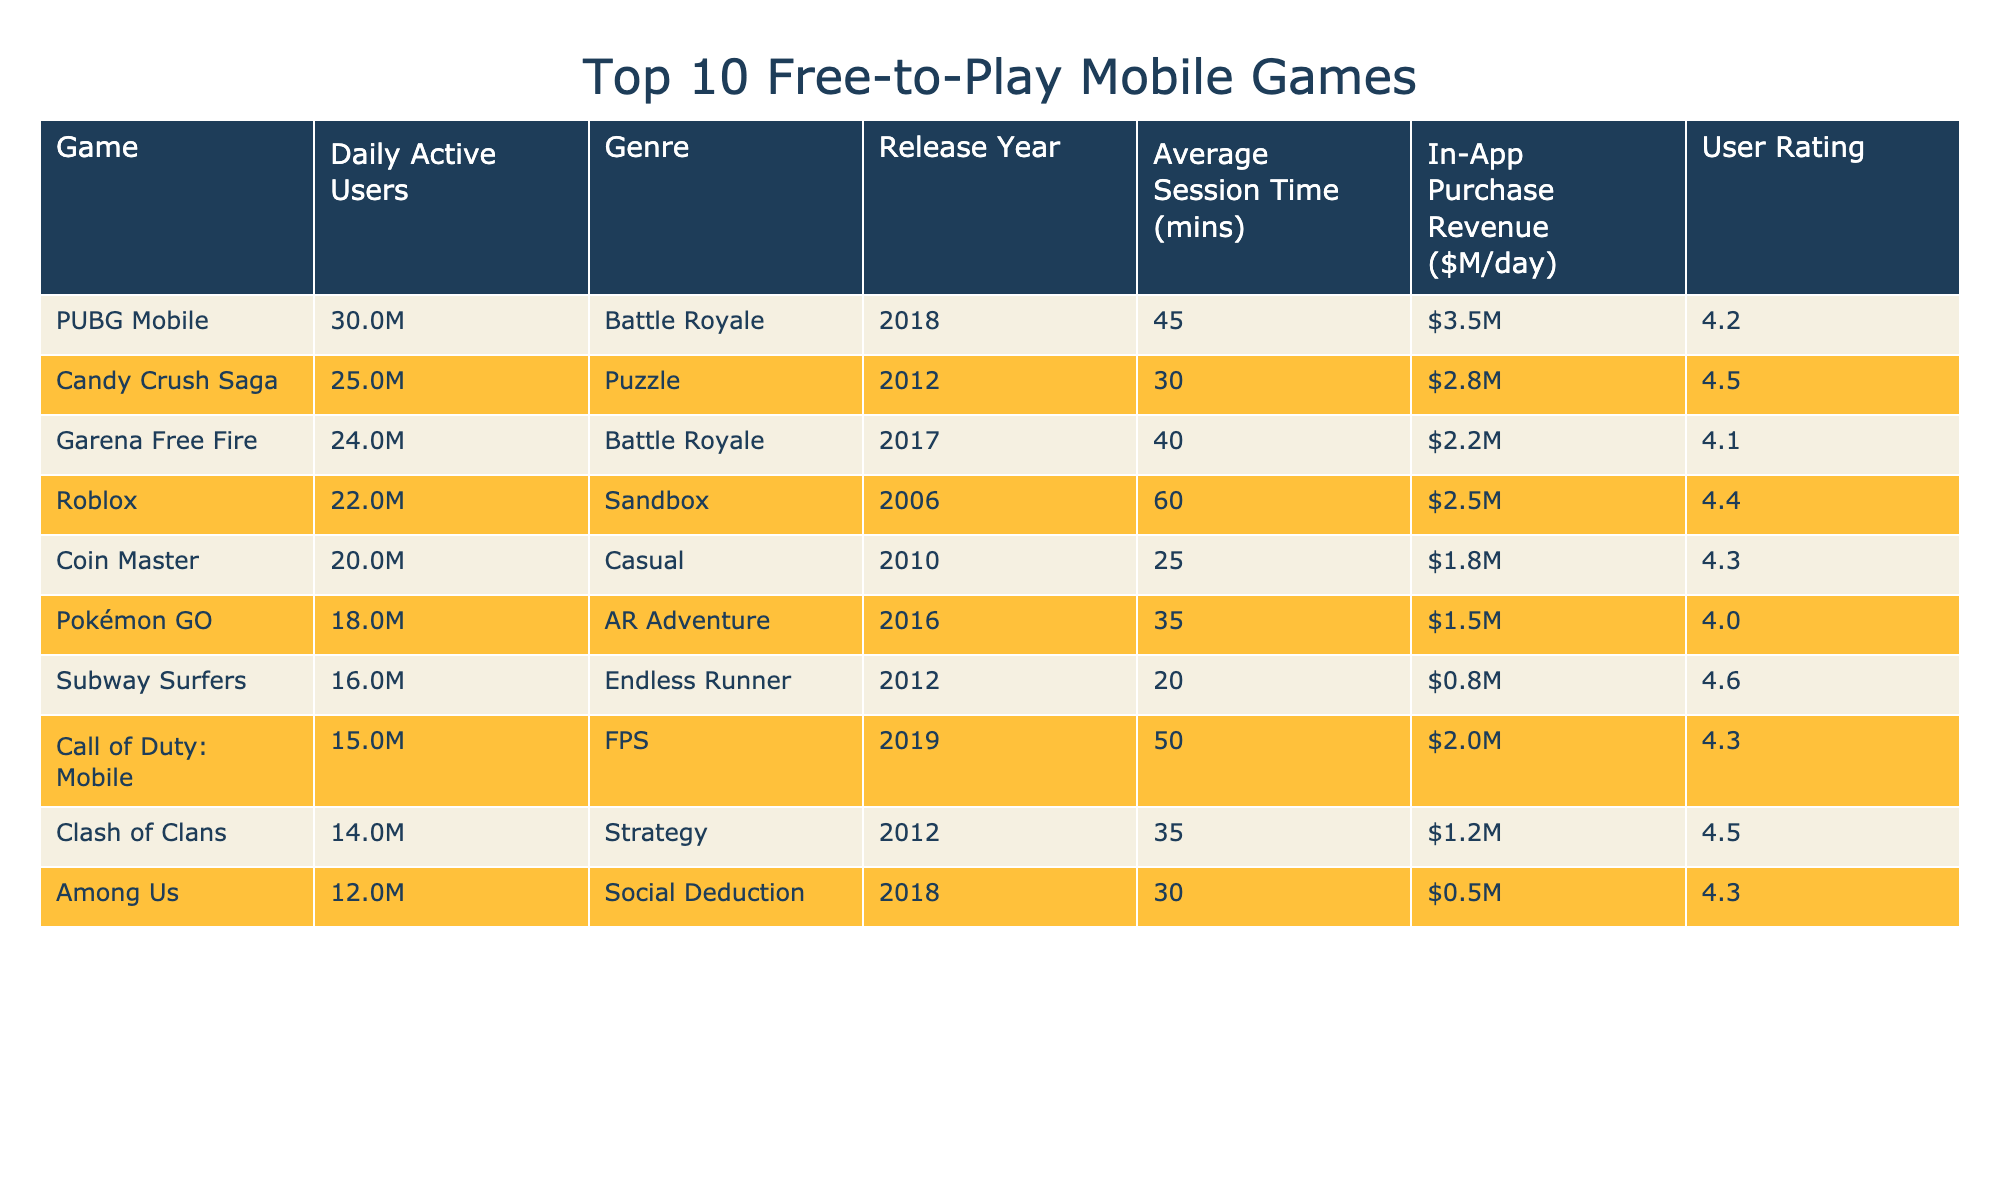What's the game with the highest daily active users? Referring to the table, the game with the highest daily active users is PUBG Mobile, which has 30,000,000 users.
Answer: PUBG Mobile Which game was released most recently? Looking at the release year column, Call of Duty: Mobile was released in 2019, making it the most recent game on the list.
Answer: Call of Duty: Mobile What is the average user rating of the top 10 games? To find the average user rating, we add all the ratings: (4.2 + 4.5 + 4.1 + 4.4 + 4.3 + 4.0 + 4.6 + 4.3 + 4.5 + 4.3) = 43.3, divide by 10 gives us an average of 4.33.
Answer: 4.3 Is there a significant difference between the daily active users of Candy Crush Saga and Call of Duty: Mobile? Candy Crush Saga has 25,000,000 daily active users while Call of Duty: Mobile has 15,000,000. The difference is 10,000,000, which is significant.
Answer: Yes Which genre has the highest average session time? The session times are: Battle Royale (45, 40), Puzzle (30), Sandbox (60), Casual (25), AR Adventure (35), Endless Runner (20), FPS (50), Strategy (35), Social Deduction (30). The highest average session time comes from Roblox at 60 minutes.
Answer: Sandbox How many games have more than 20 million daily active users? From the table, the games with more than 20 million users are PUBG Mobile, Candy Crush Saga, Garena Free Fire, Roblox, and Coin Master, totaling five games.
Answer: 5 What is the in-app purchase revenue of Subway Surfers? The revenue column shows that Subway Surfers has an in-app purchase revenue of $0.8 million per day.
Answer: $0.8M Is the user rating of Pokémon GO higher than that of Among Us? Pokémon GO has a user rating of 4.0 while Among Us has a rating of 4.3. Since 4.0 is less than 4.3, the statement is false.
Answer: No What is the difference between the daily active users of the highest and lowest game? The highest, PUBG Mobile, has 30,000,000 users, and the lowest, Among Us, has 12,000,000 users. The difference is 30,000,000 - 12,000,000 = 18,000,000.
Answer: 18M Which game has the lowest in-app purchase revenue per day? Among the listed games, Among Us has the lowest in-app purchase revenue of $0.5 million per day.
Answer: Among Us 